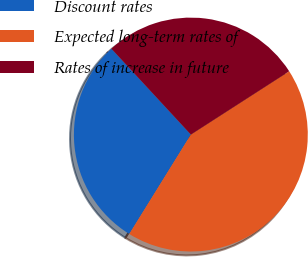<chart> <loc_0><loc_0><loc_500><loc_500><pie_chart><fcel>Discount rates<fcel>Expected long-term rates of<fcel>Rates of increase in future<nl><fcel>29.29%<fcel>42.93%<fcel>27.78%<nl></chart> 